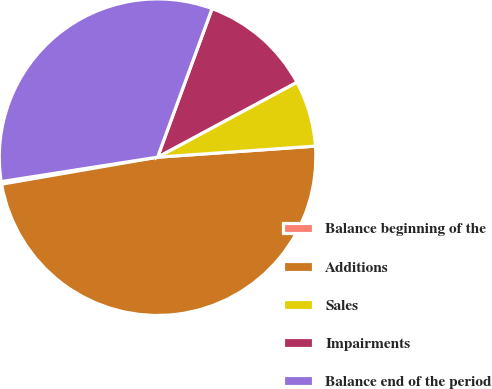Convert chart to OTSL. <chart><loc_0><loc_0><loc_500><loc_500><pie_chart><fcel>Balance beginning of the<fcel>Additions<fcel>Sales<fcel>Impairments<fcel>Balance end of the period<nl><fcel>0.26%<fcel>48.39%<fcel>6.74%<fcel>11.55%<fcel>33.07%<nl></chart> 